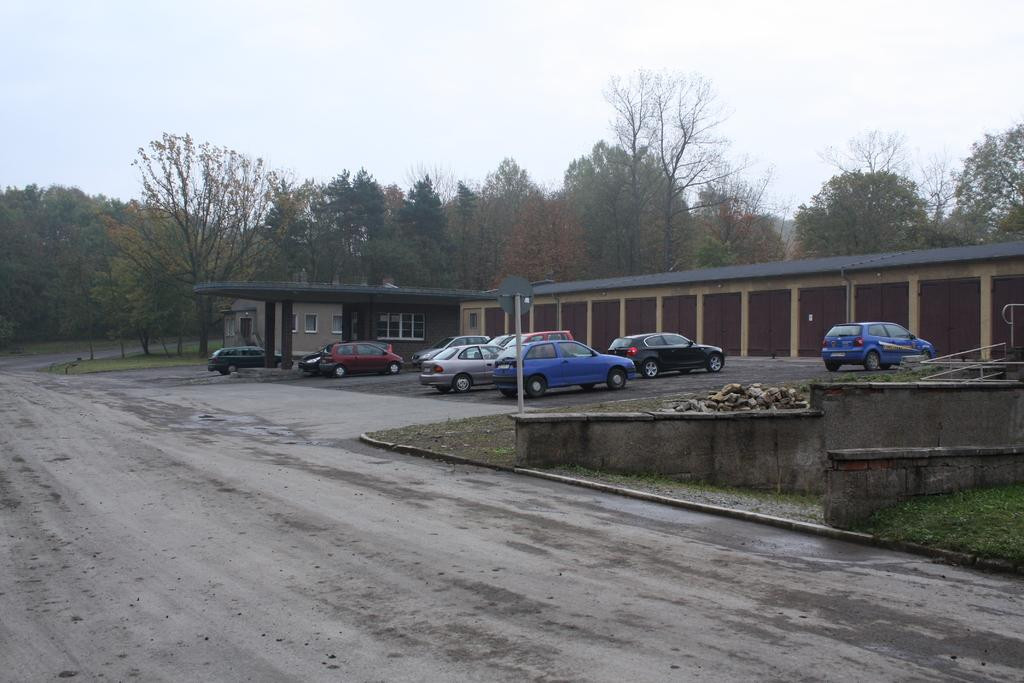What is located at the bottom of the image? There is a road at the bottom of the image. What type of vehicles can be seen in the image? Cars are visible in the image. What natural elements are present in the image? There are trees in the image. What type of structure is in the image? There is a building in the image. What is visible at the top of the image? The sky is visible at the top of the image. What hobbies do the trees in the image enjoy? Trees do not have hobbies, as they are inanimate objects. 